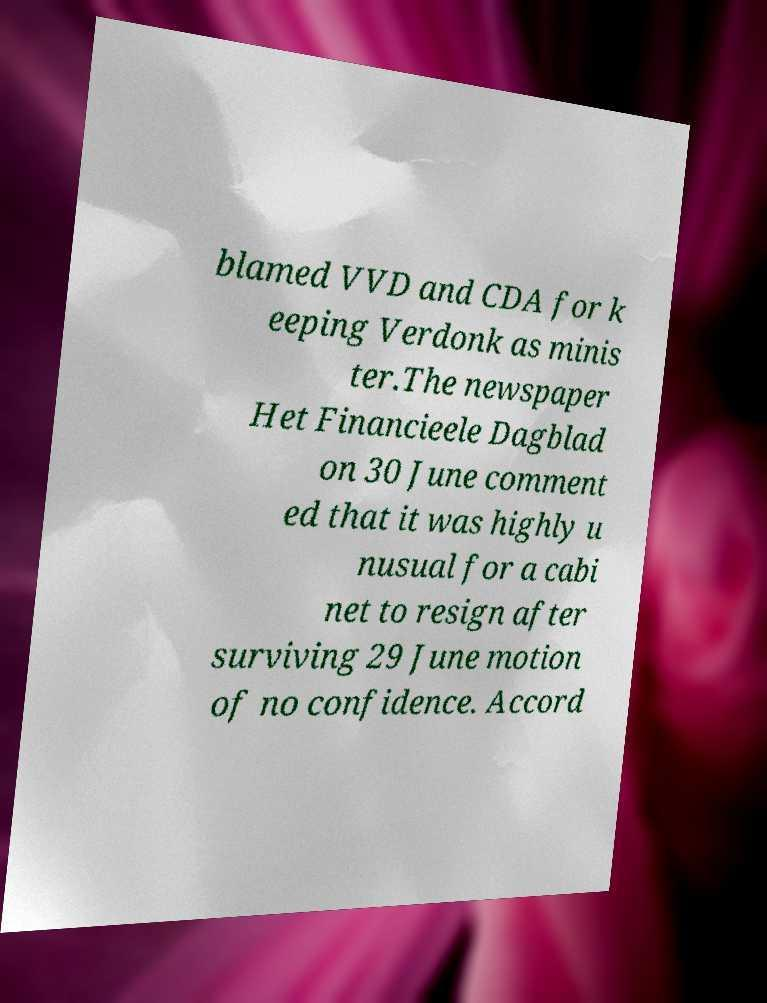Please read and relay the text visible in this image. What does it say? blamed VVD and CDA for k eeping Verdonk as minis ter.The newspaper Het Financieele Dagblad on 30 June comment ed that it was highly u nusual for a cabi net to resign after surviving 29 June motion of no confidence. Accord 